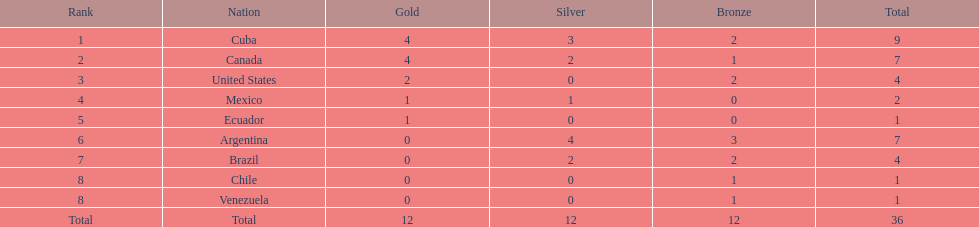In which position does mexico rank? 4. 